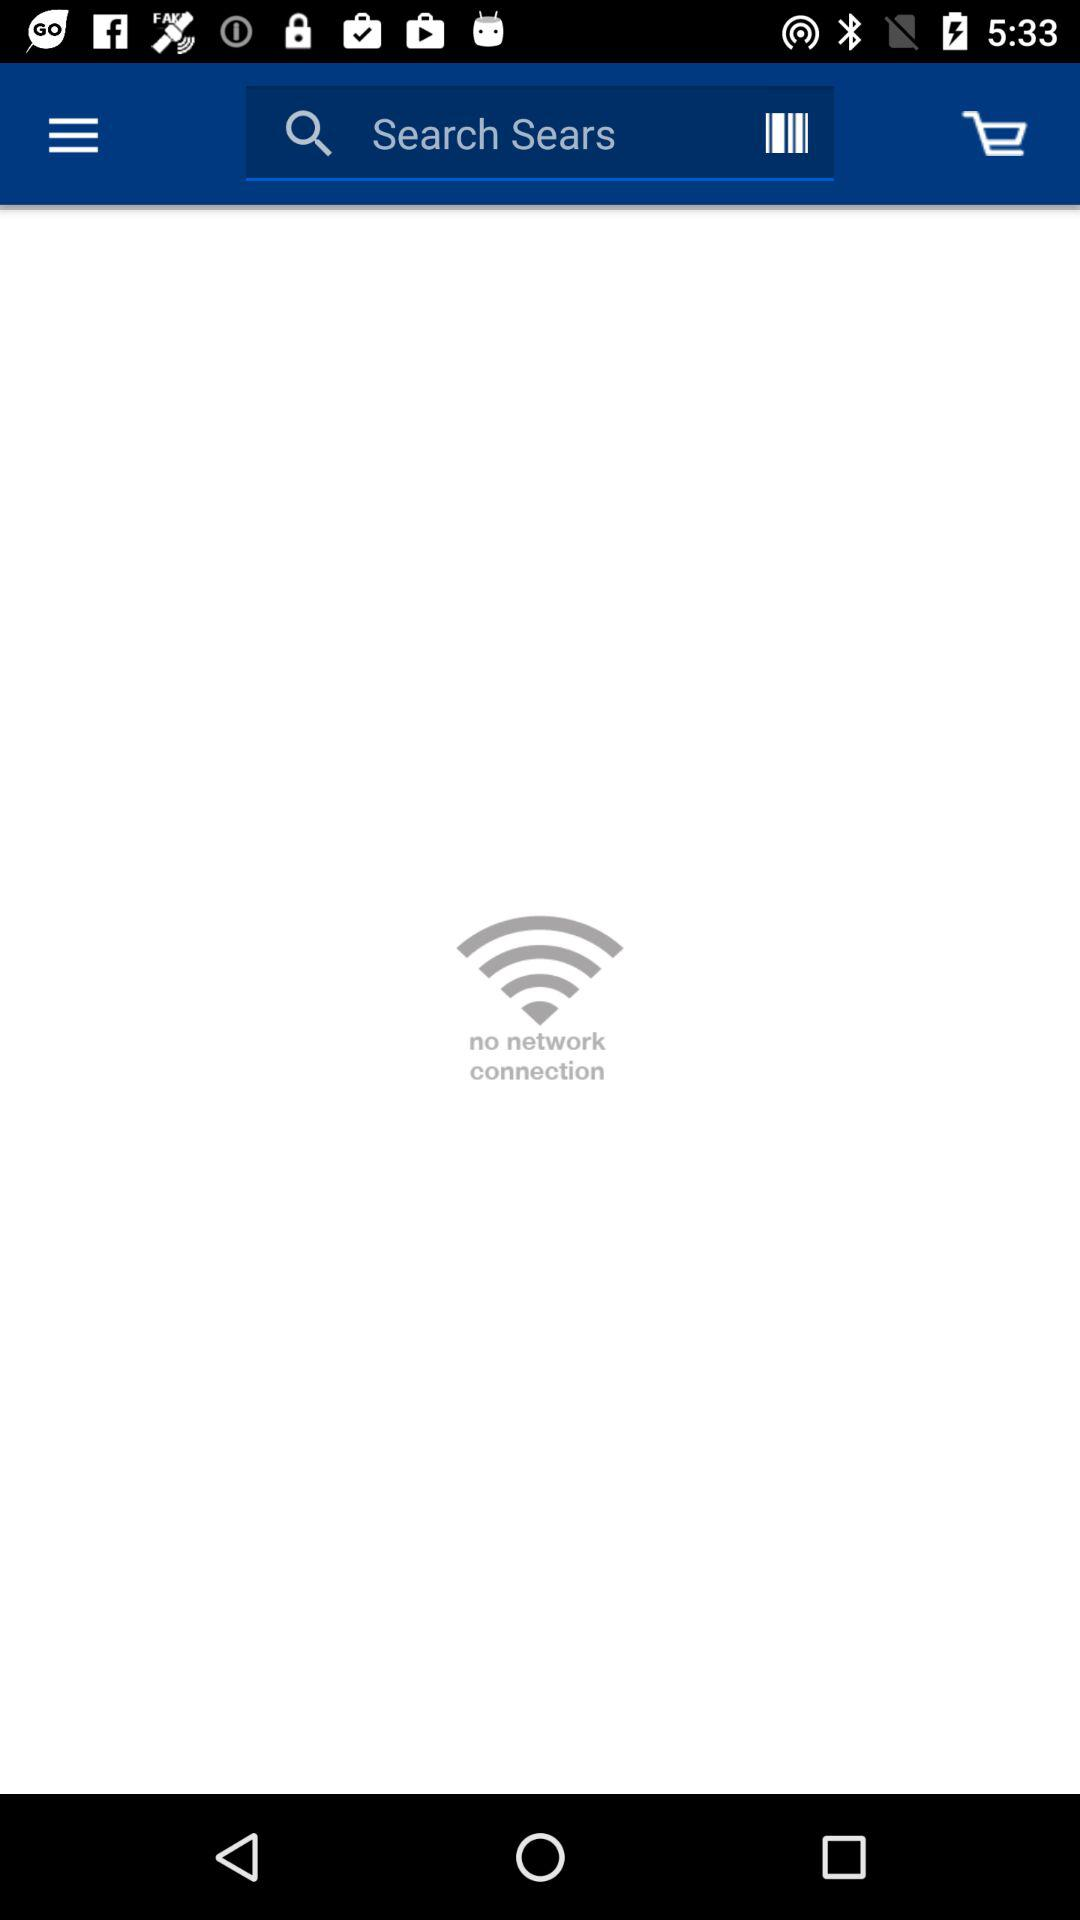Is there any network connection? There is no network connection. 